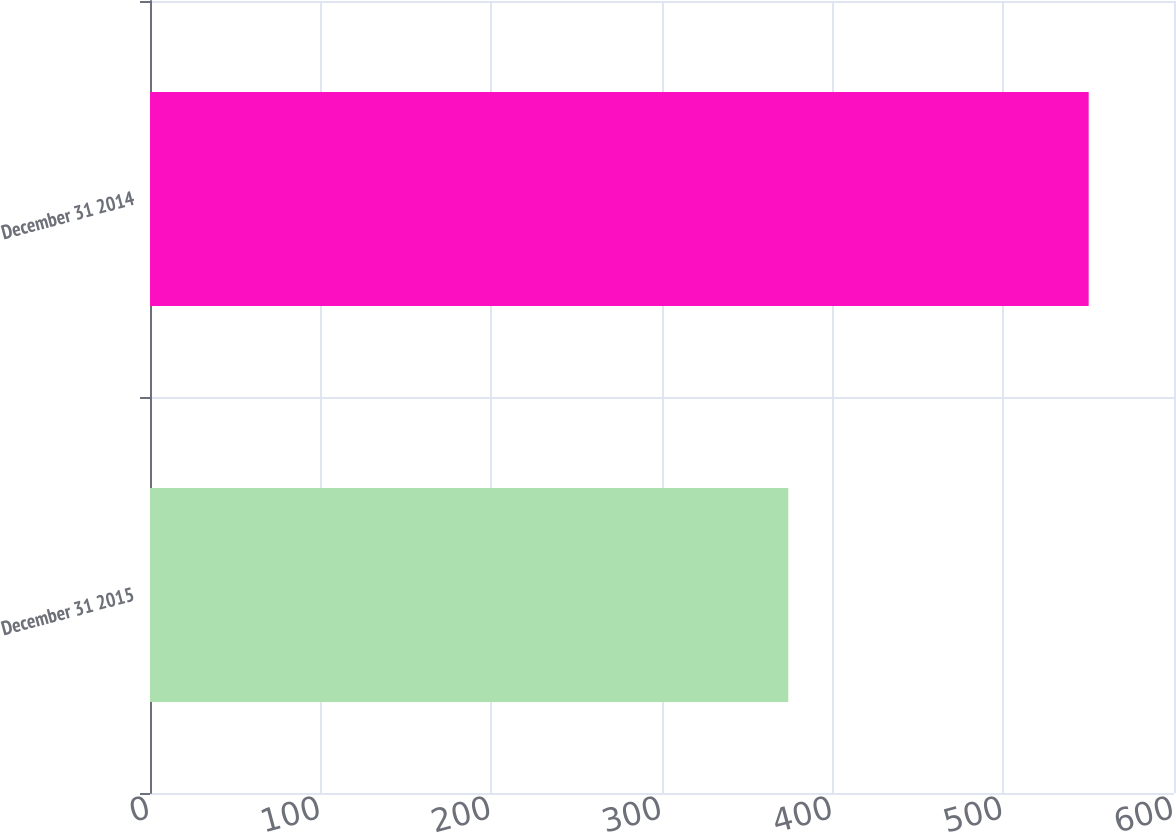Convert chart to OTSL. <chart><loc_0><loc_0><loc_500><loc_500><bar_chart><fcel>December 31 2015<fcel>December 31 2014<nl><fcel>374<fcel>550<nl></chart> 